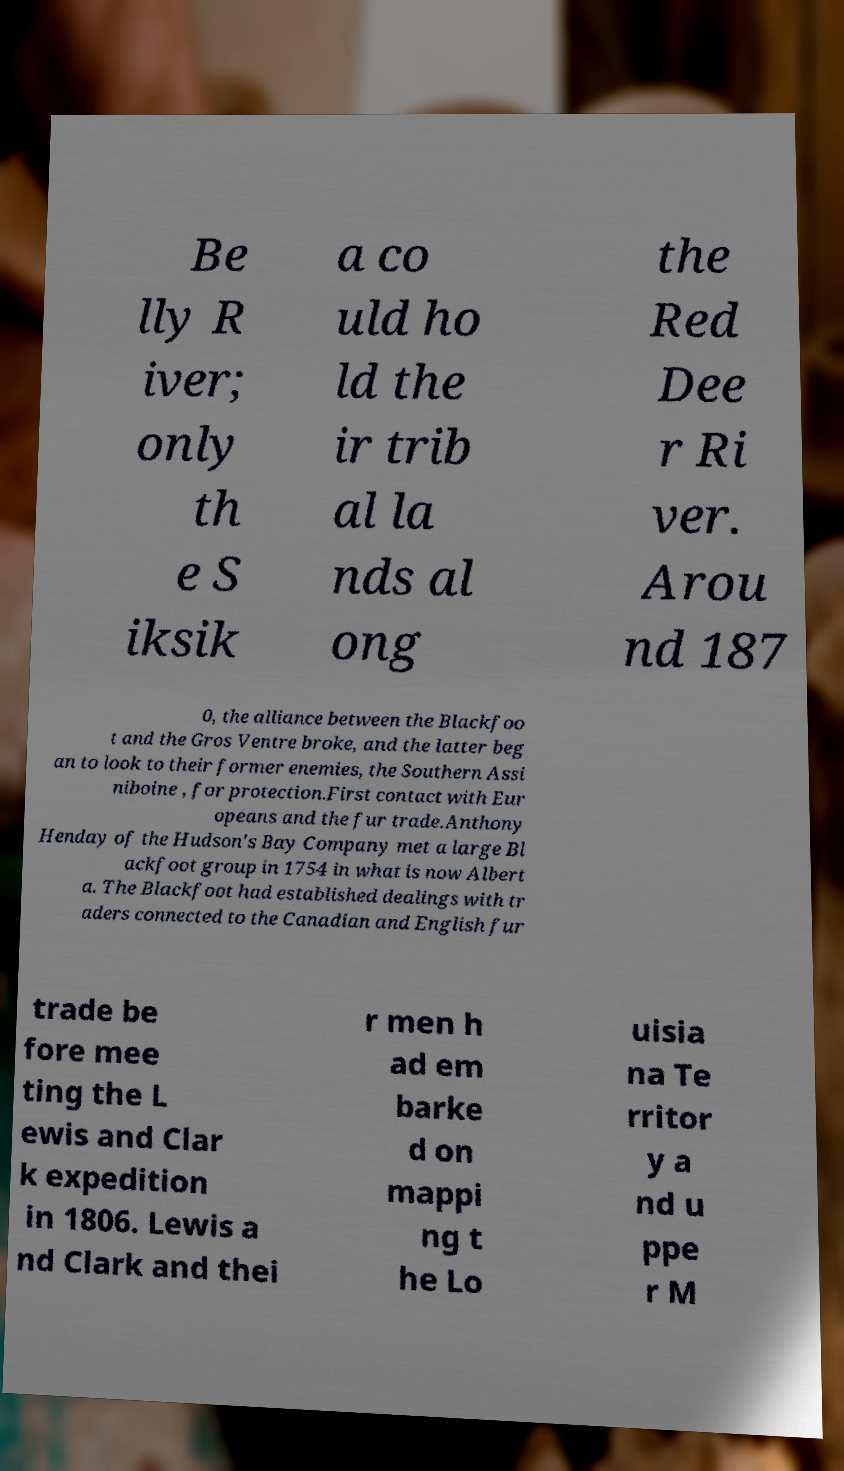There's text embedded in this image that I need extracted. Can you transcribe it verbatim? Be lly R iver; only th e S iksik a co uld ho ld the ir trib al la nds al ong the Red Dee r Ri ver. Arou nd 187 0, the alliance between the Blackfoo t and the Gros Ventre broke, and the latter beg an to look to their former enemies, the Southern Assi niboine , for protection.First contact with Eur opeans and the fur trade.Anthony Henday of the Hudson's Bay Company met a large Bl ackfoot group in 1754 in what is now Albert a. The Blackfoot had established dealings with tr aders connected to the Canadian and English fur trade be fore mee ting the L ewis and Clar k expedition in 1806. Lewis a nd Clark and thei r men h ad em barke d on mappi ng t he Lo uisia na Te rritor y a nd u ppe r M 